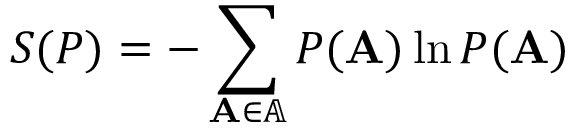Convert formula to latex. <formula><loc_0><loc_0><loc_500><loc_500>S ( P ) = - \sum _ { A \in \mathbb { A } } P ( A ) \ln P ( A )</formula> 